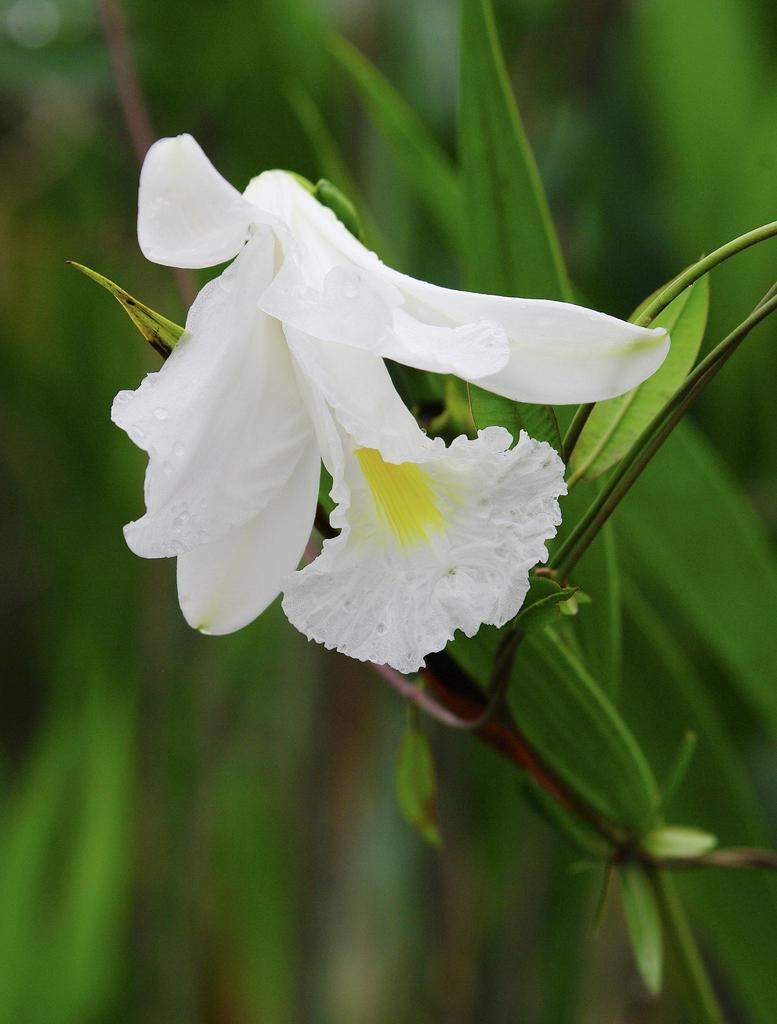Could you give a brief overview of what you see in this image? In this picture we can see white color flower on a plant. Here we can see leaves. 